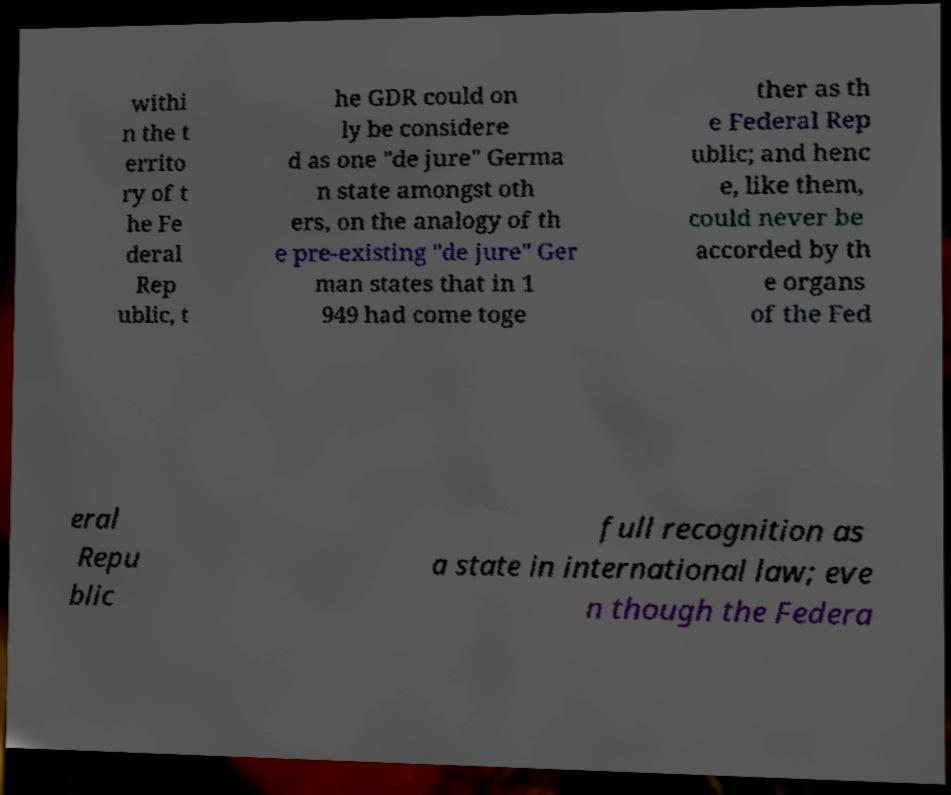There's text embedded in this image that I need extracted. Can you transcribe it verbatim? withi n the t errito ry of t he Fe deral Rep ublic, t he GDR could on ly be considere d as one "de jure" Germa n state amongst oth ers, on the analogy of th e pre-existing "de jure" Ger man states that in 1 949 had come toge ther as th e Federal Rep ublic; and henc e, like them, could never be accorded by th e organs of the Fed eral Repu blic full recognition as a state in international law; eve n though the Federa 